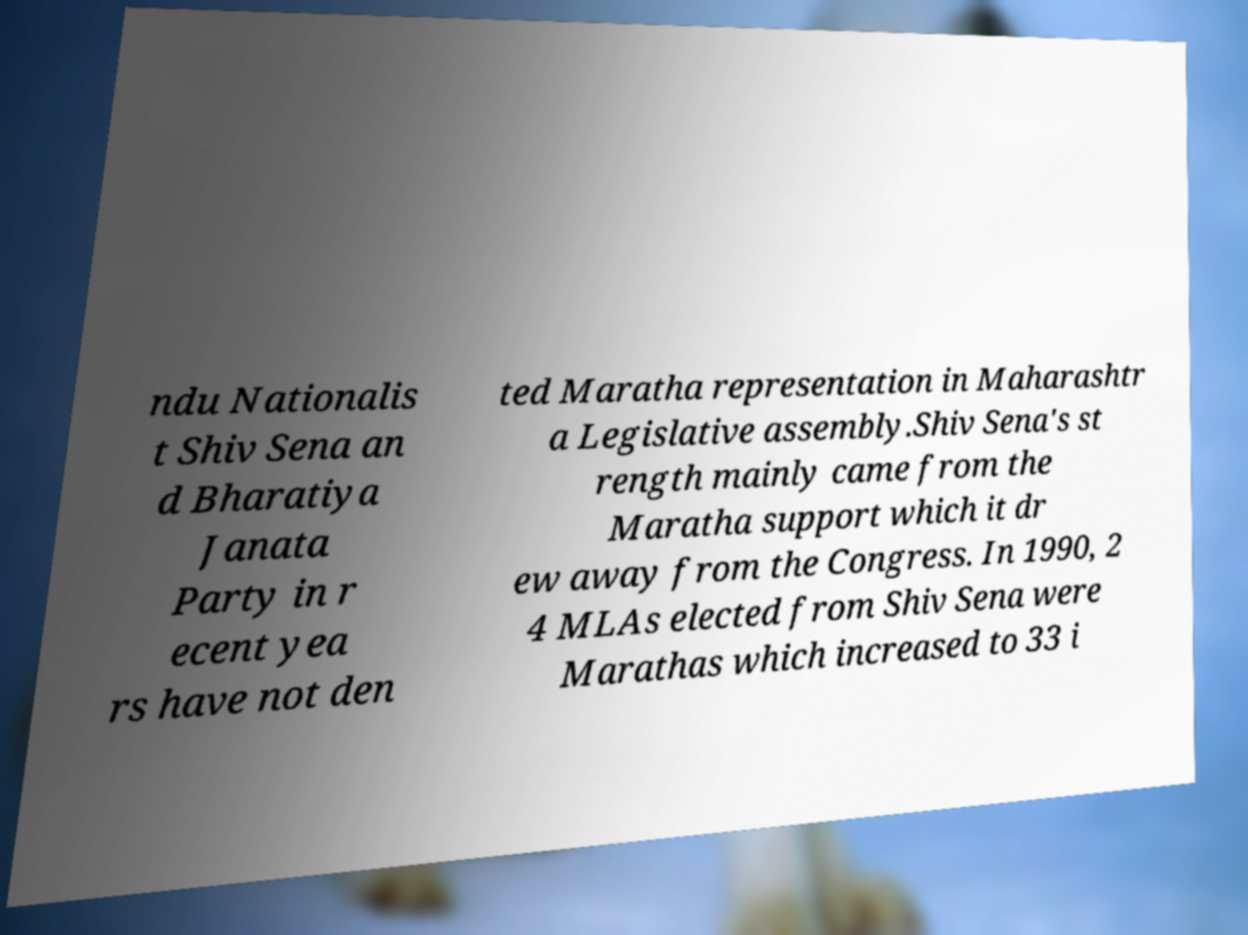There's text embedded in this image that I need extracted. Can you transcribe it verbatim? ndu Nationalis t Shiv Sena an d Bharatiya Janata Party in r ecent yea rs have not den ted Maratha representation in Maharashtr a Legislative assembly.Shiv Sena's st rength mainly came from the Maratha support which it dr ew away from the Congress. In 1990, 2 4 MLAs elected from Shiv Sena were Marathas which increased to 33 i 